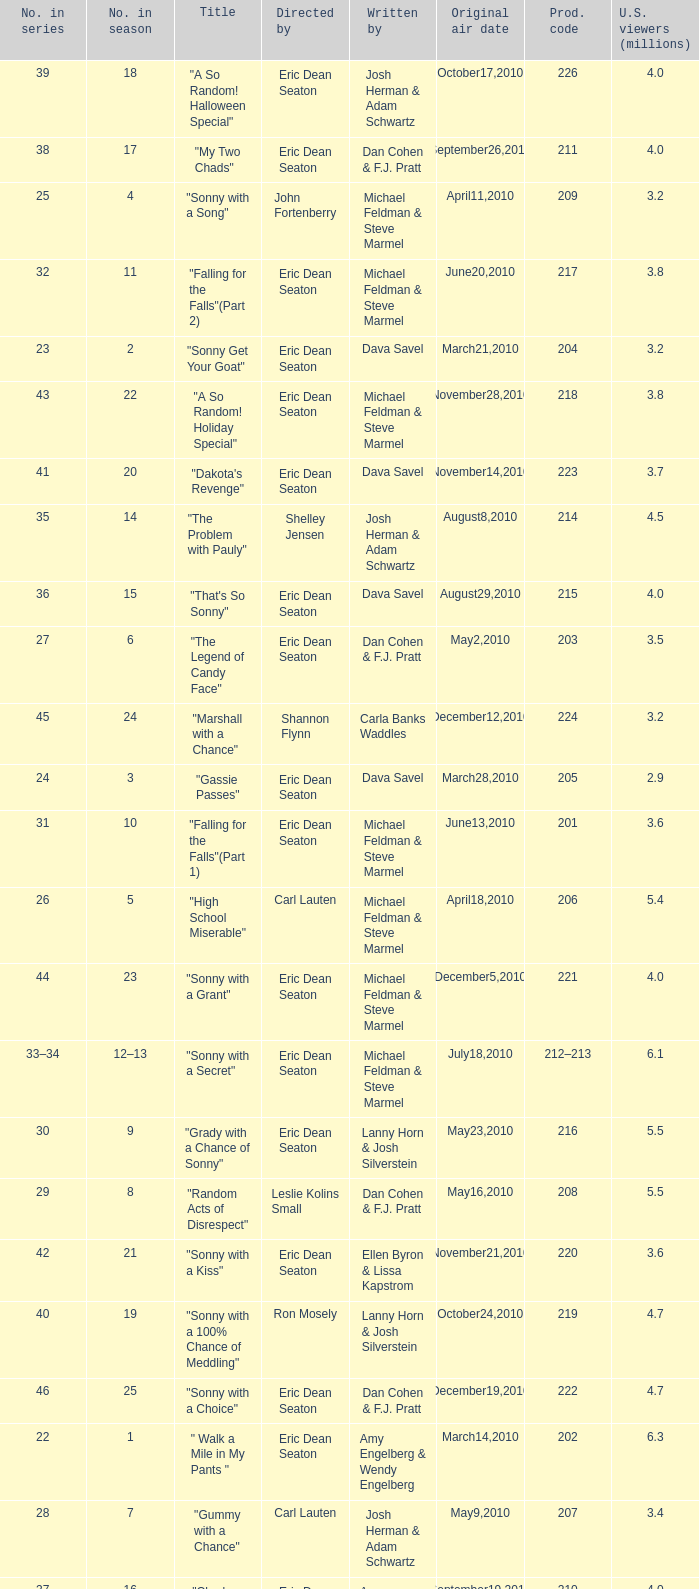Can you give me this table as a dict? {'header': ['No. in series', 'No. in season', 'Title', 'Directed by', 'Written by', 'Original air date', 'Prod. code', 'U.S. viewers (millions)'], 'rows': [['39', '18', '"A So Random! Halloween Special"', 'Eric Dean Seaton', 'Josh Herman & Adam Schwartz', 'October17,2010', '226', '4.0'], ['38', '17', '"My Two Chads"', 'Eric Dean Seaton', 'Dan Cohen & F.J. Pratt', 'September26,2010', '211', '4.0'], ['25', '4', '"Sonny with a Song"', 'John Fortenberry', 'Michael Feldman & Steve Marmel', 'April11,2010', '209', '3.2'], ['32', '11', '"Falling for the Falls"(Part 2)', 'Eric Dean Seaton', 'Michael Feldman & Steve Marmel', 'June20,2010', '217', '3.8'], ['23', '2', '"Sonny Get Your Goat"', 'Eric Dean Seaton', 'Dava Savel', 'March21,2010', '204', '3.2'], ['43', '22', '"A So Random! Holiday Special"', 'Eric Dean Seaton', 'Michael Feldman & Steve Marmel', 'November28,2010', '218', '3.8'], ['41', '20', '"Dakota\'s Revenge"', 'Eric Dean Seaton', 'Dava Savel', 'November14,2010', '223', '3.7'], ['35', '14', '"The Problem with Pauly"', 'Shelley Jensen', 'Josh Herman & Adam Schwartz', 'August8,2010', '214', '4.5'], ['36', '15', '"That\'s So Sonny"', 'Eric Dean Seaton', 'Dava Savel', 'August29,2010', '215', '4.0'], ['27', '6', '"The Legend of Candy Face"', 'Eric Dean Seaton', 'Dan Cohen & F.J. Pratt', 'May2,2010', '203', '3.5'], ['45', '24', '"Marshall with a Chance"', 'Shannon Flynn', 'Carla Banks Waddles', 'December12,2010', '224', '3.2'], ['24', '3', '"Gassie Passes"', 'Eric Dean Seaton', 'Dava Savel', 'March28,2010', '205', '2.9'], ['31', '10', '"Falling for the Falls"(Part 1)', 'Eric Dean Seaton', 'Michael Feldman & Steve Marmel', 'June13,2010', '201', '3.6'], ['26', '5', '"High School Miserable"', 'Carl Lauten', 'Michael Feldman & Steve Marmel', 'April18,2010', '206', '5.4'], ['44', '23', '"Sonny with a Grant"', 'Eric Dean Seaton', 'Michael Feldman & Steve Marmel', 'December5,2010', '221', '4.0'], ['33–34', '12–13', '"Sonny with a Secret"', 'Eric Dean Seaton', 'Michael Feldman & Steve Marmel', 'July18,2010', '212–213', '6.1'], ['30', '9', '"Grady with a Chance of Sonny"', 'Eric Dean Seaton', 'Lanny Horn & Josh Silverstein', 'May23,2010', '216', '5.5'], ['29', '8', '"Random Acts of Disrespect"', 'Leslie Kolins Small', 'Dan Cohen & F.J. Pratt', 'May16,2010', '208', '5.5'], ['42', '21', '"Sonny with a Kiss"', 'Eric Dean Seaton', 'Ellen Byron & Lissa Kapstrom', 'November21,2010', '220', '3.6'], ['40', '19', '"Sonny with a 100% Chance of Meddling"', 'Ron Mosely', 'Lanny Horn & Josh Silverstein', 'October24,2010', '219', '4.7'], ['46', '25', '"Sonny with a Choice"', 'Eric Dean Seaton', 'Dan Cohen & F.J. Pratt', 'December19,2010', '222', '4.7'], ['22', '1', '" Walk a Mile in My Pants "', 'Eric Dean Seaton', 'Amy Engelberg & Wendy Engelberg', 'March14,2010', '202', '6.3'], ['28', '7', '"Gummy with a Chance"', 'Carl Lauten', 'Josh Herman & Adam Schwartz', 'May9,2010', '207', '3.4'], ['37', '16', '"Chad Without a Chance"', 'Eric Dean Seaton', 'Amy Engelberg & Wendy Engelberg', 'September19,2010', '210', '4.0']]} Who directed the episode that 6.3 million u.s. viewers saw? Eric Dean Seaton. 